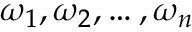Convert formula to latex. <formula><loc_0><loc_0><loc_500><loc_500>\omega _ { 1 } , \omega _ { 2 } , \dots , \omega _ { n }</formula> 